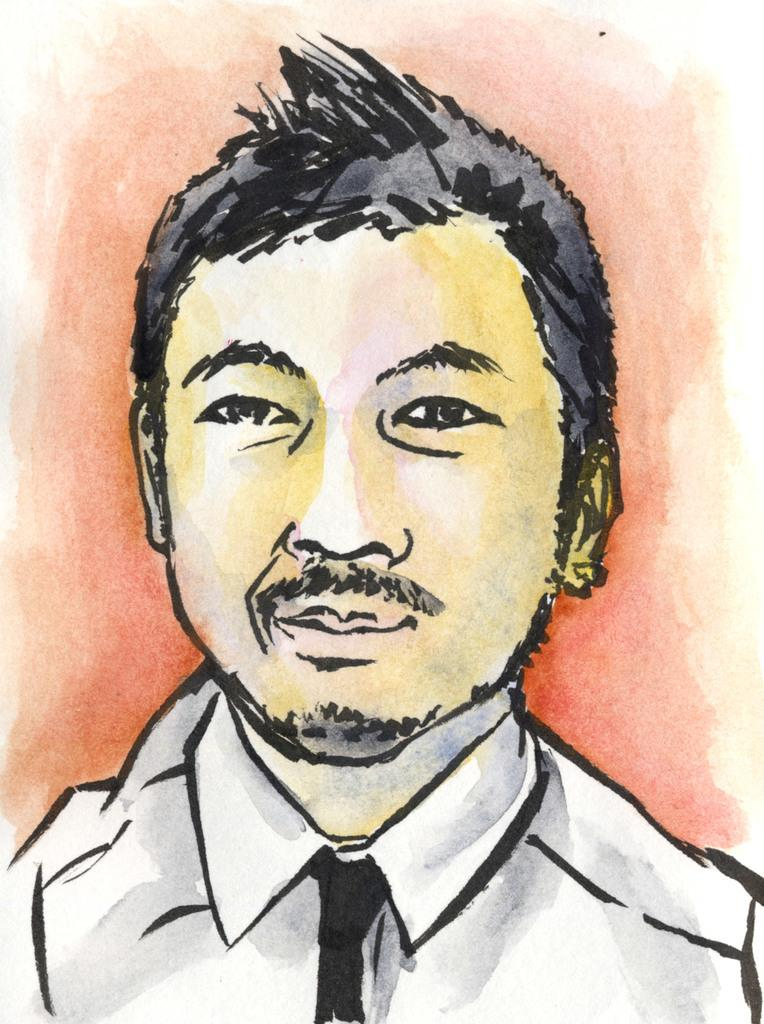What is depicted in the image? There is a painting of a man in the image. What type of treatment does the man in the painting receive from the pail? There is no pail present in the image, and therefore no treatment can be observed. 